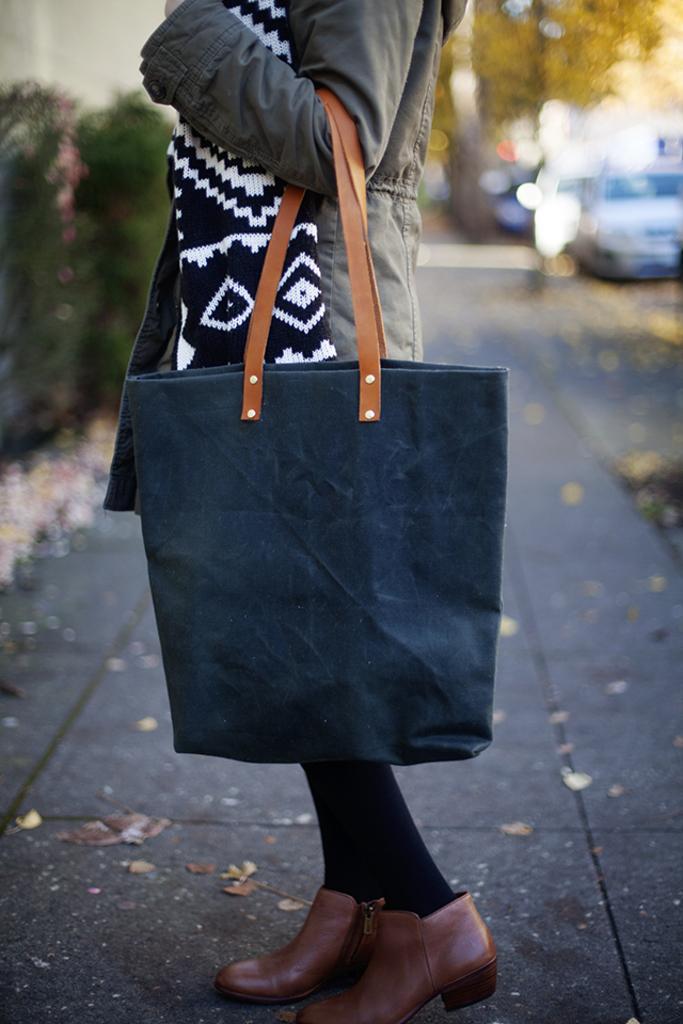Can you describe this image briefly? This woman wore scarf, jacket and holding this blue color handbag. Background is blurry and we can able to see trees, plants and a vehicles on road. 